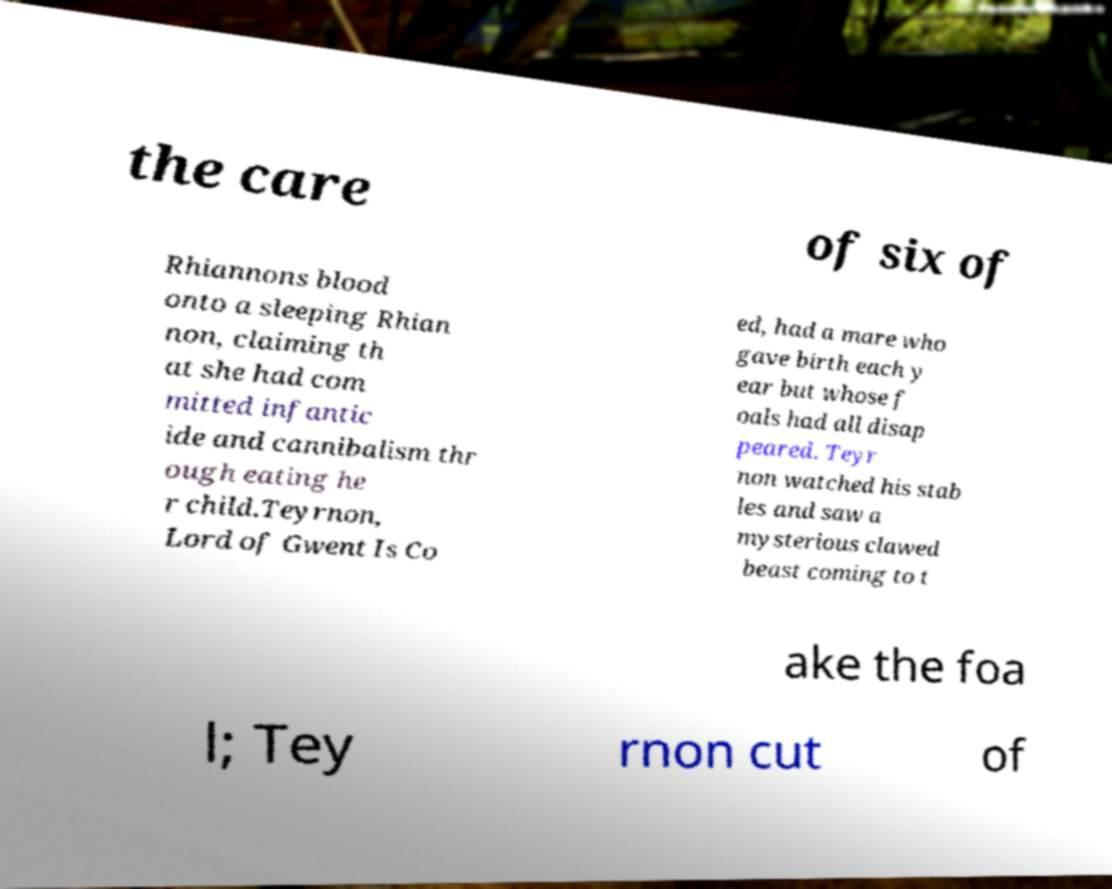Can you accurately transcribe the text from the provided image for me? the care of six of Rhiannons blood onto a sleeping Rhian non, claiming th at she had com mitted infantic ide and cannibalism thr ough eating he r child.Teyrnon, Lord of Gwent Is Co ed, had a mare who gave birth each y ear but whose f oals had all disap peared. Teyr non watched his stab les and saw a mysterious clawed beast coming to t ake the foa l; Tey rnon cut of 